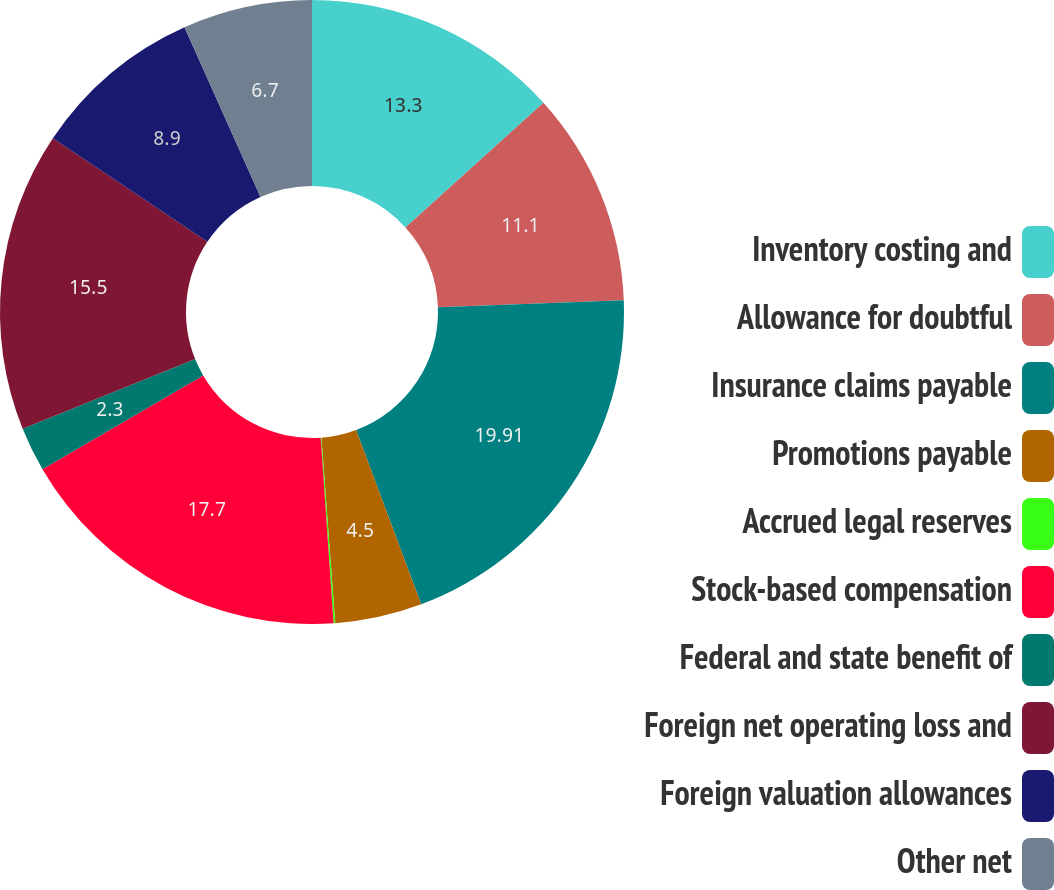<chart> <loc_0><loc_0><loc_500><loc_500><pie_chart><fcel>Inventory costing and<fcel>Allowance for doubtful<fcel>Insurance claims payable<fcel>Promotions payable<fcel>Accrued legal reserves<fcel>Stock-based compensation<fcel>Federal and state benefit of<fcel>Foreign net operating loss and<fcel>Foreign valuation allowances<fcel>Other net<nl><fcel>13.3%<fcel>11.1%<fcel>19.91%<fcel>4.5%<fcel>0.09%<fcel>17.7%<fcel>2.3%<fcel>15.5%<fcel>8.9%<fcel>6.7%<nl></chart> 